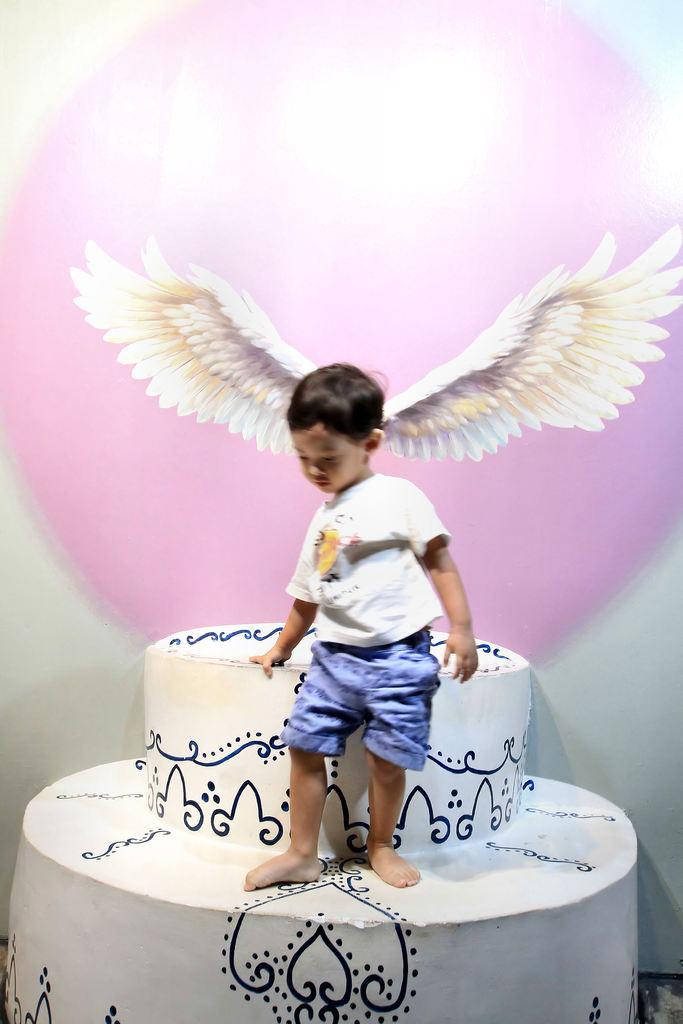What is the main subject of the image? There is an object in the image. What is the boy doing in relation to the object? A boy is standing on the object. What can be seen in the background of the image? There are wings in the background of the image. What type of copper shake can be seen in the boy's hand in the image? There is no copper shake present in the image, nor is the boy holding anything in his hand. 